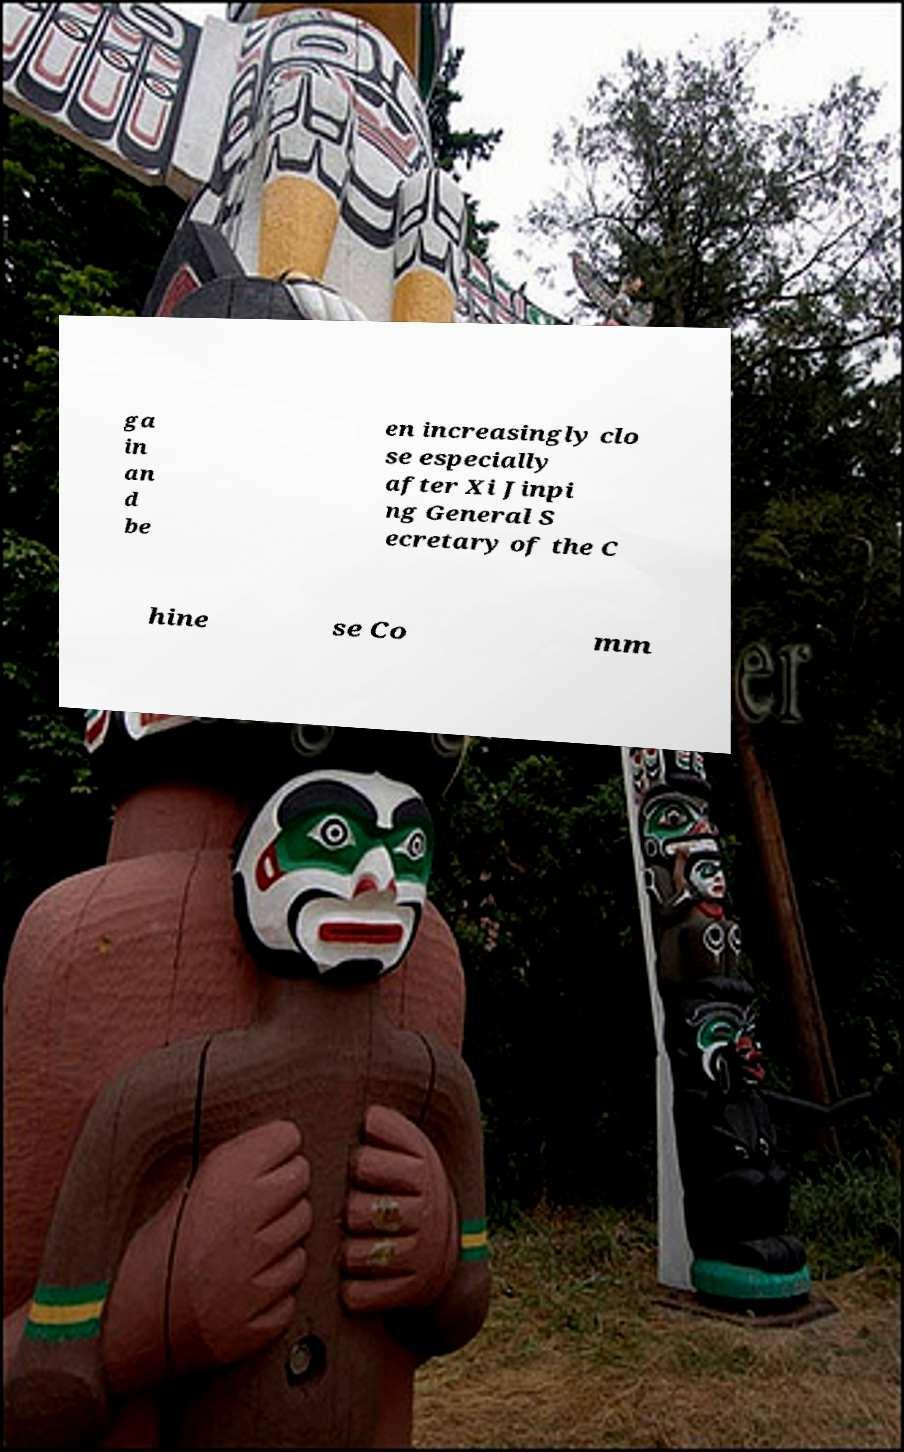Can you accurately transcribe the text from the provided image for me? ga in an d be en increasingly clo se especially after Xi Jinpi ng General S ecretary of the C hine se Co mm 